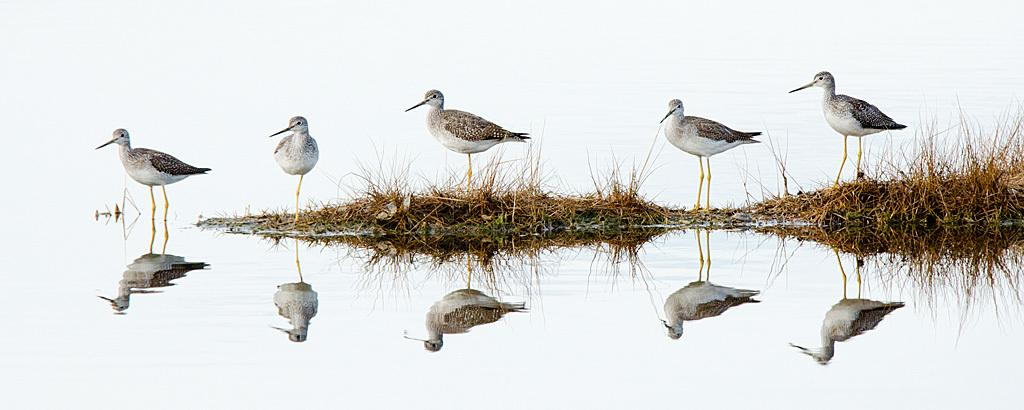What type of animals can be seen in the image? There are birds in the image. Where are the birds located? The birds are standing on the grass and on the water. What can be observed about the birds' reflection in the water? There is a reflection of the birds on the water. What type of chalk can be seen in the image? There is no chalk present in the image. What books are the birds reading in the image? There are no books or reading activity depicted in the image. 